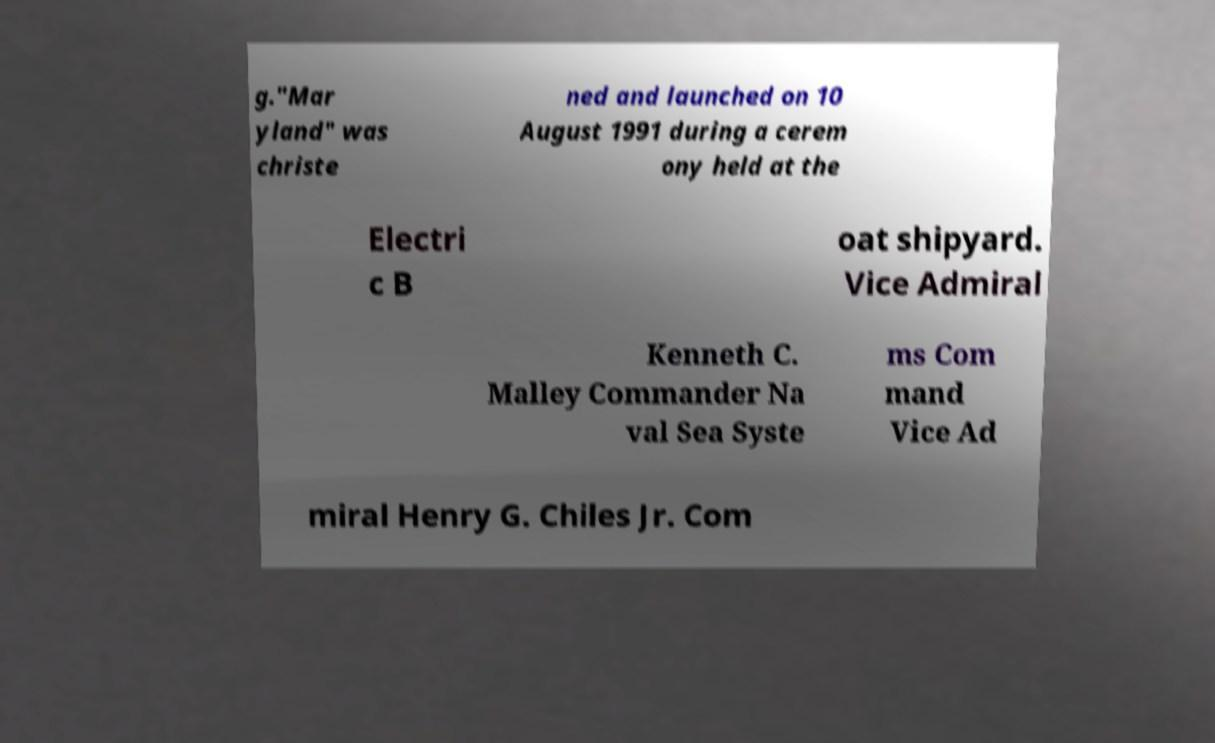There's text embedded in this image that I need extracted. Can you transcribe it verbatim? g."Mar yland" was christe ned and launched on 10 August 1991 during a cerem ony held at the Electri c B oat shipyard. Vice Admiral Kenneth C. Malley Commander Na val Sea Syste ms Com mand Vice Ad miral Henry G. Chiles Jr. Com 